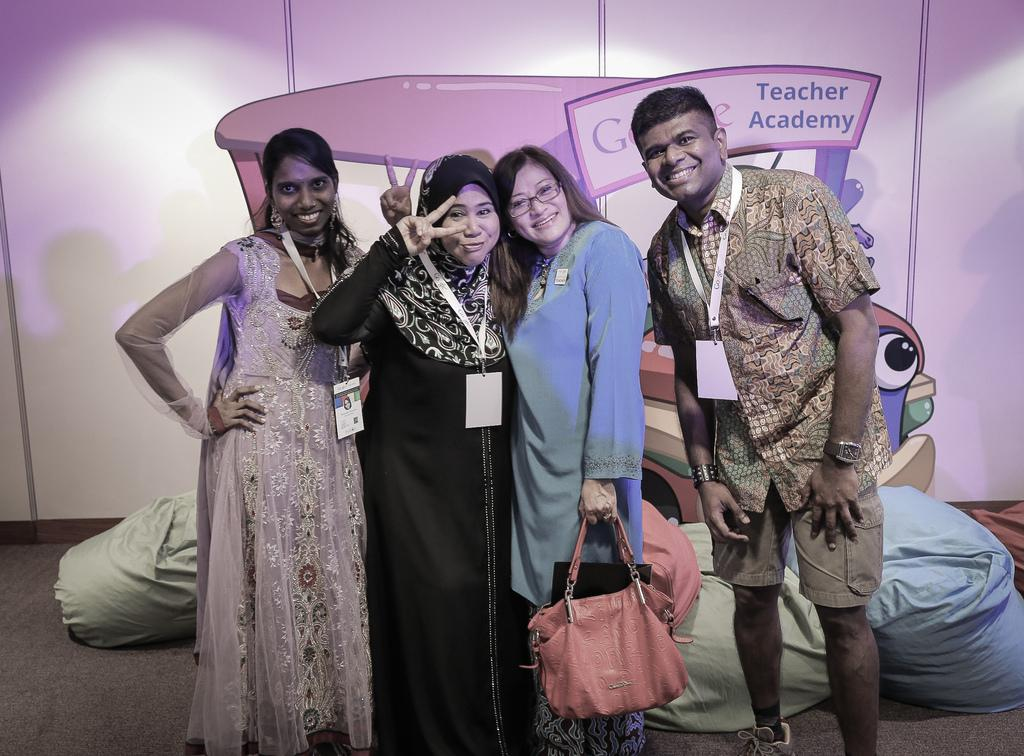How many people are in the image? There is a group of four people in the image. Can you describe the composition of the group? Three of the people are women, and one is a man. What are the people in the image doing? The group is posing for a camera. What type of bubble can be seen floating near the man in the image? There is no bubble present in the image. Can you describe the man's muscles in the image? The image does not provide enough detail to describe the man's muscles. 